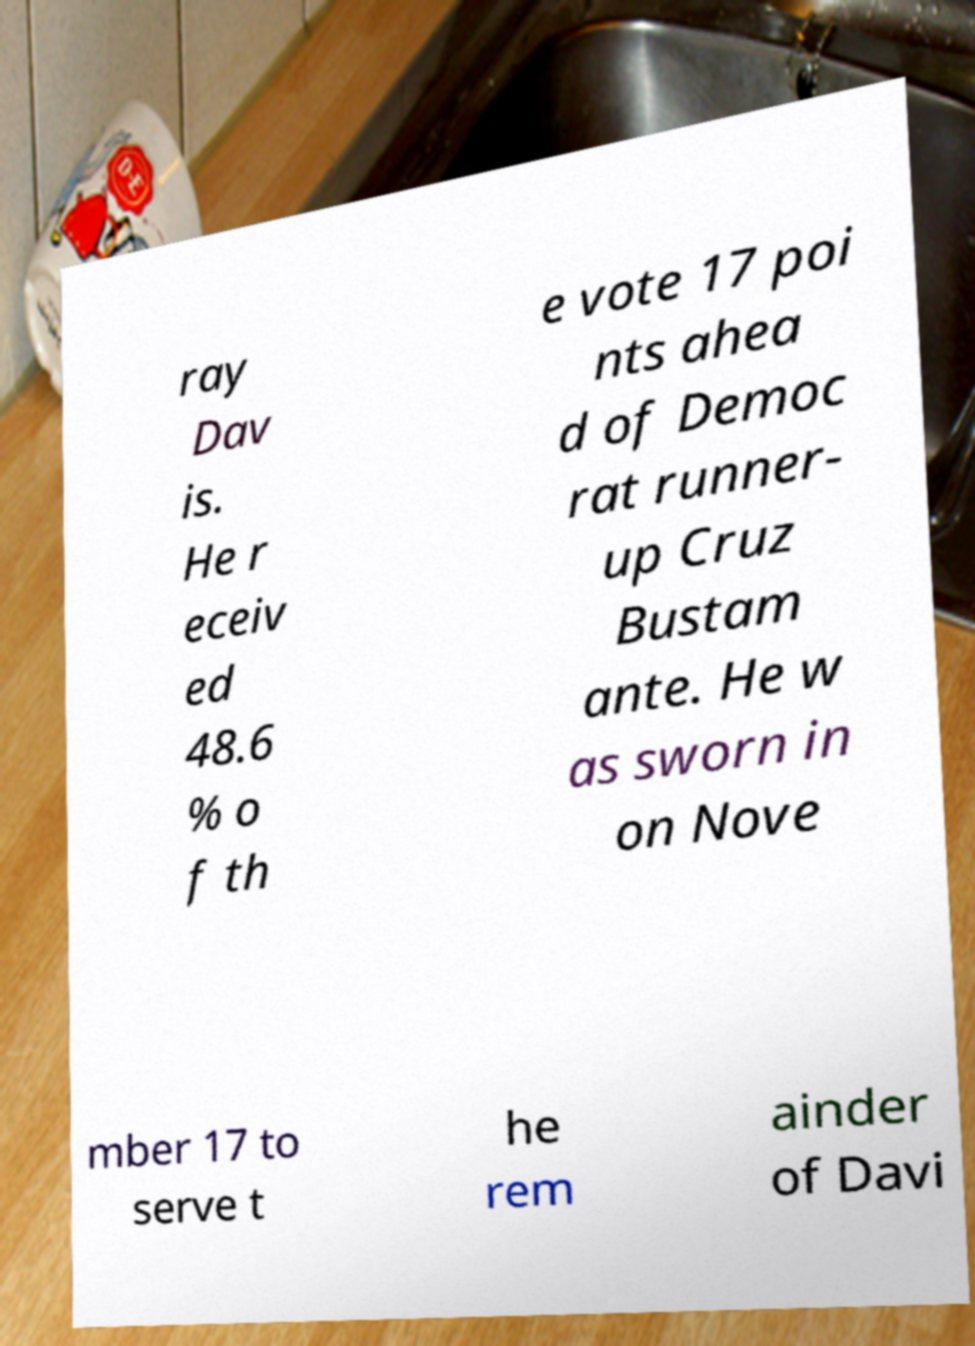I need the written content from this picture converted into text. Can you do that? ray Dav is. He r eceiv ed 48.6 % o f th e vote 17 poi nts ahea d of Democ rat runner- up Cruz Bustam ante. He w as sworn in on Nove mber 17 to serve t he rem ainder of Davi 